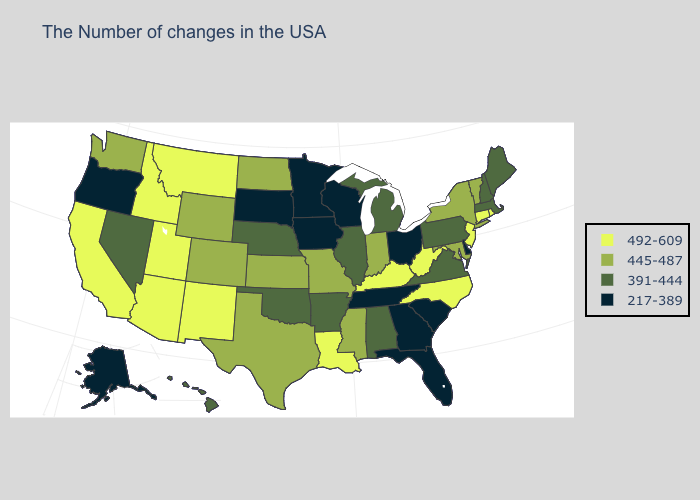What is the value of Montana?
Keep it brief. 492-609. Does Alabama have the same value as Maine?
Short answer required. Yes. Name the states that have a value in the range 492-609?
Short answer required. Rhode Island, Connecticut, New Jersey, North Carolina, West Virginia, Kentucky, Louisiana, New Mexico, Utah, Montana, Arizona, Idaho, California. Does Connecticut have the lowest value in the USA?
Short answer required. No. What is the lowest value in the South?
Concise answer only. 217-389. Does Alaska have the lowest value in the West?
Answer briefly. Yes. What is the lowest value in the South?
Be succinct. 217-389. Does Massachusetts have the lowest value in the Northeast?
Write a very short answer. Yes. Is the legend a continuous bar?
Short answer required. No. What is the value of New York?
Be succinct. 445-487. Name the states that have a value in the range 391-444?
Be succinct. Maine, Massachusetts, New Hampshire, Pennsylvania, Virginia, Michigan, Alabama, Illinois, Arkansas, Nebraska, Oklahoma, Nevada, Hawaii. Name the states that have a value in the range 492-609?
Concise answer only. Rhode Island, Connecticut, New Jersey, North Carolina, West Virginia, Kentucky, Louisiana, New Mexico, Utah, Montana, Arizona, Idaho, California. What is the value of Utah?
Short answer required. 492-609. Among the states that border Delaware , which have the lowest value?
Give a very brief answer. Pennsylvania. 